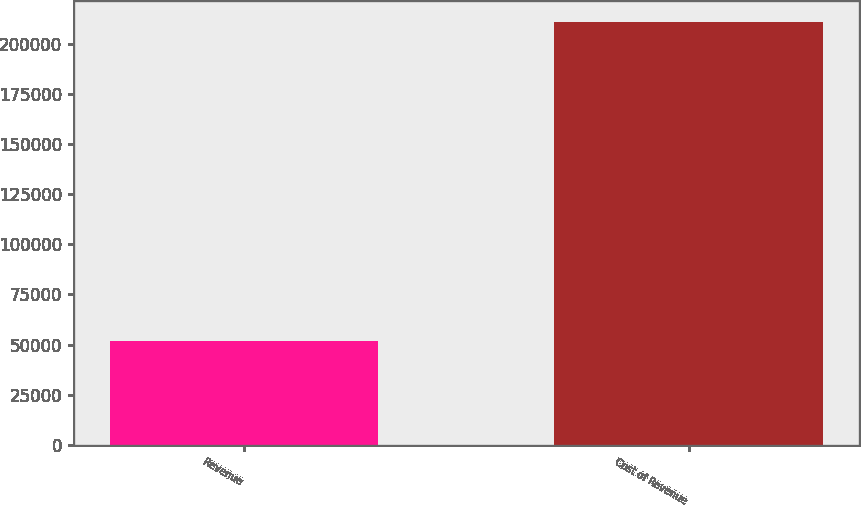<chart> <loc_0><loc_0><loc_500><loc_500><bar_chart><fcel>Revenue<fcel>Cost of Revenue<nl><fcel>51953<fcel>210916<nl></chart> 